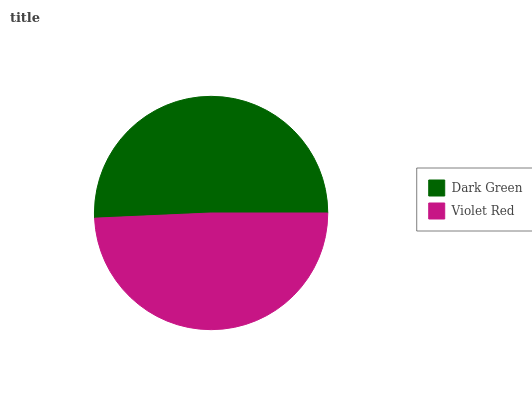Is Violet Red the minimum?
Answer yes or no. Yes. Is Dark Green the maximum?
Answer yes or no. Yes. Is Violet Red the maximum?
Answer yes or no. No. Is Dark Green greater than Violet Red?
Answer yes or no. Yes. Is Violet Red less than Dark Green?
Answer yes or no. Yes. Is Violet Red greater than Dark Green?
Answer yes or no. No. Is Dark Green less than Violet Red?
Answer yes or no. No. Is Dark Green the high median?
Answer yes or no. Yes. Is Violet Red the low median?
Answer yes or no. Yes. Is Violet Red the high median?
Answer yes or no. No. Is Dark Green the low median?
Answer yes or no. No. 